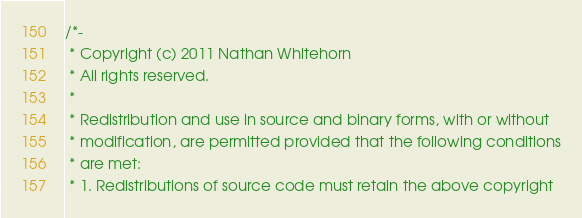<code> <loc_0><loc_0><loc_500><loc_500><_C_>/*-
 * Copyright (c) 2011 Nathan Whitehorn
 * All rights reserved.
 *
 * Redistribution and use in source and binary forms, with or without
 * modification, are permitted provided that the following conditions
 * are met:
 * 1. Redistributions of source code must retain the above copyright</code> 